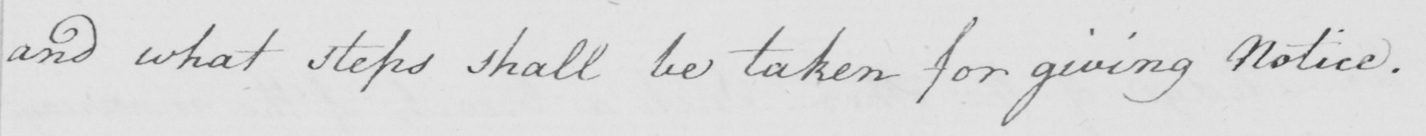Please transcribe the handwritten text in this image. and what steps shall be taken for giving notice. 